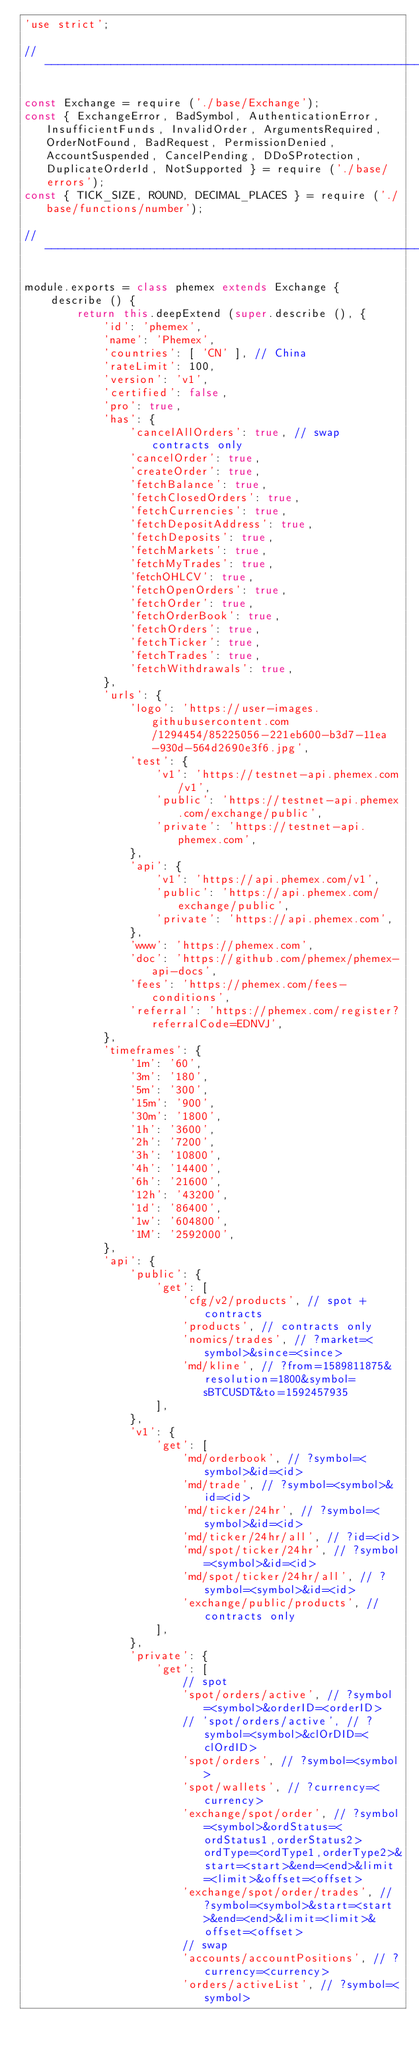Convert code to text. <code><loc_0><loc_0><loc_500><loc_500><_JavaScript_>'use strict';

// ----------------------------------------------------------------------------

const Exchange = require ('./base/Exchange');
const { ExchangeError, BadSymbol, AuthenticationError, InsufficientFunds, InvalidOrder, ArgumentsRequired, OrderNotFound, BadRequest, PermissionDenied, AccountSuspended, CancelPending, DDoSProtection, DuplicateOrderId, NotSupported } = require ('./base/errors');
const { TICK_SIZE, ROUND, DECIMAL_PLACES } = require ('./base/functions/number');

// ----------------------------------------------------------------------------

module.exports = class phemex extends Exchange {
    describe () {
        return this.deepExtend (super.describe (), {
            'id': 'phemex',
            'name': 'Phemex',
            'countries': [ 'CN' ], // China
            'rateLimit': 100,
            'version': 'v1',
            'certified': false,
            'pro': true,
            'has': {
                'cancelAllOrders': true, // swap contracts only
                'cancelOrder': true,
                'createOrder': true,
                'fetchBalance': true,
                'fetchClosedOrders': true,
                'fetchCurrencies': true,
                'fetchDepositAddress': true,
                'fetchDeposits': true,
                'fetchMarkets': true,
                'fetchMyTrades': true,
                'fetchOHLCV': true,
                'fetchOpenOrders': true,
                'fetchOrder': true,
                'fetchOrderBook': true,
                'fetchOrders': true,
                'fetchTicker': true,
                'fetchTrades': true,
                'fetchWithdrawals': true,
            },
            'urls': {
                'logo': 'https://user-images.githubusercontent.com/1294454/85225056-221eb600-b3d7-11ea-930d-564d2690e3f6.jpg',
                'test': {
                    'v1': 'https://testnet-api.phemex.com/v1',
                    'public': 'https://testnet-api.phemex.com/exchange/public',
                    'private': 'https://testnet-api.phemex.com',
                },
                'api': {
                    'v1': 'https://api.phemex.com/v1',
                    'public': 'https://api.phemex.com/exchange/public',
                    'private': 'https://api.phemex.com',
                },
                'www': 'https://phemex.com',
                'doc': 'https://github.com/phemex/phemex-api-docs',
                'fees': 'https://phemex.com/fees-conditions',
                'referral': 'https://phemex.com/register?referralCode=EDNVJ',
            },
            'timeframes': {
                '1m': '60',
                '3m': '180',
                '5m': '300',
                '15m': '900',
                '30m': '1800',
                '1h': '3600',
                '2h': '7200',
                '3h': '10800',
                '4h': '14400',
                '6h': '21600',
                '12h': '43200',
                '1d': '86400',
                '1w': '604800',
                '1M': '2592000',
            },
            'api': {
                'public': {
                    'get': [
                        'cfg/v2/products', // spot + contracts
                        'products', // contracts only
                        'nomics/trades', // ?market=<symbol>&since=<since>
                        'md/kline', // ?from=1589811875&resolution=1800&symbol=sBTCUSDT&to=1592457935
                    ],
                },
                'v1': {
                    'get': [
                        'md/orderbook', // ?symbol=<symbol>&id=<id>
                        'md/trade', // ?symbol=<symbol>&id=<id>
                        'md/ticker/24hr', // ?symbol=<symbol>&id=<id>
                        'md/ticker/24hr/all', // ?id=<id>
                        'md/spot/ticker/24hr', // ?symbol=<symbol>&id=<id>
                        'md/spot/ticker/24hr/all', // ?symbol=<symbol>&id=<id>
                        'exchange/public/products', // contracts only
                    ],
                },
                'private': {
                    'get': [
                        // spot
                        'spot/orders/active', // ?symbol=<symbol>&orderID=<orderID>
                        // 'spot/orders/active', // ?symbol=<symbol>&clOrDID=<clOrdID>
                        'spot/orders', // ?symbol=<symbol>
                        'spot/wallets', // ?currency=<currency>
                        'exchange/spot/order', // ?symbol=<symbol>&ordStatus=<ordStatus1,orderStatus2>ordType=<ordType1,orderType2>&start=<start>&end=<end>&limit=<limit>&offset=<offset>
                        'exchange/spot/order/trades', // ?symbol=<symbol>&start=<start>&end=<end>&limit=<limit>&offset=<offset>
                        // swap
                        'accounts/accountPositions', // ?currency=<currency>
                        'orders/activeList', // ?symbol=<symbol></code> 